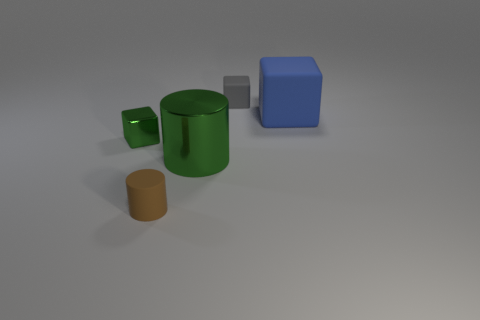What size is the rubber cylinder that is to the left of the tiny object that is behind the tiny metallic object?
Ensure brevity in your answer.  Small. Are there the same number of big shiny objects that are behind the gray object and big blue matte objects on the left side of the large block?
Your answer should be very brief. Yes. What is the thing that is behind the matte cylinder and in front of the small metallic object made of?
Ensure brevity in your answer.  Metal. Is the size of the green block the same as the green metallic object that is right of the small matte cylinder?
Make the answer very short. No. What number of other things are the same color as the big matte object?
Provide a succinct answer. 0. Is the number of rubber objects that are behind the big cylinder greater than the number of tiny cylinders?
Ensure brevity in your answer.  Yes. There is a large object to the left of the matte block that is in front of the small block that is behind the blue matte block; what is its color?
Offer a terse response. Green. Are the small gray block and the large cylinder made of the same material?
Offer a terse response. No. Is there a gray thing of the same size as the brown cylinder?
Provide a short and direct response. Yes. What material is the cylinder that is the same size as the blue object?
Ensure brevity in your answer.  Metal. 